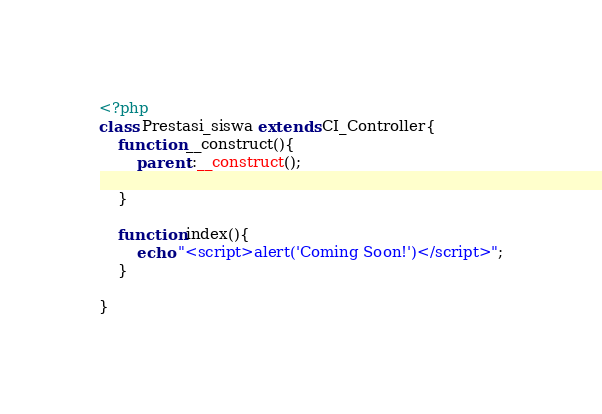Convert code to text. <code><loc_0><loc_0><loc_500><loc_500><_PHP_><?php
class Prestasi_siswa extends CI_Controller{
	function __construct(){
		parent::__construct();

	}

	function index(){
		echo "<script>alert('Coming Soon!')</script>";
	}

}</code> 